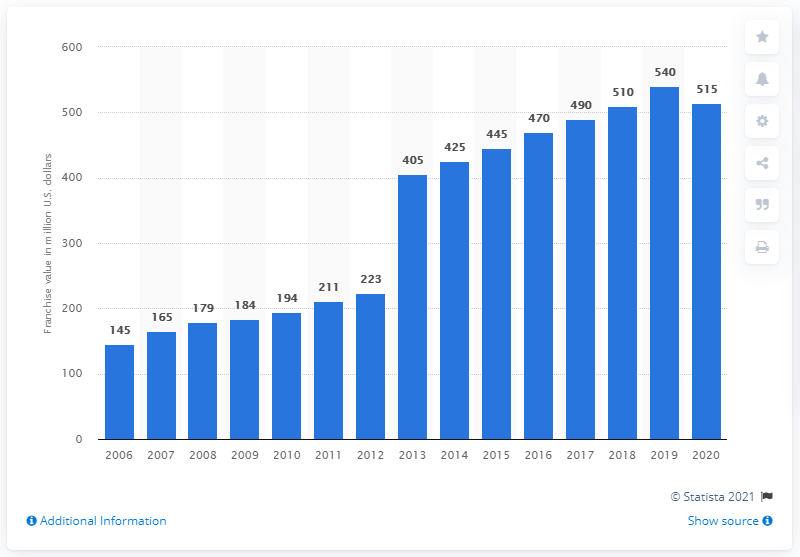Highlight a few significant elements in this photo. In 2020, the estimated value of the San Jose Sharks was approximately 515 million dollars. 